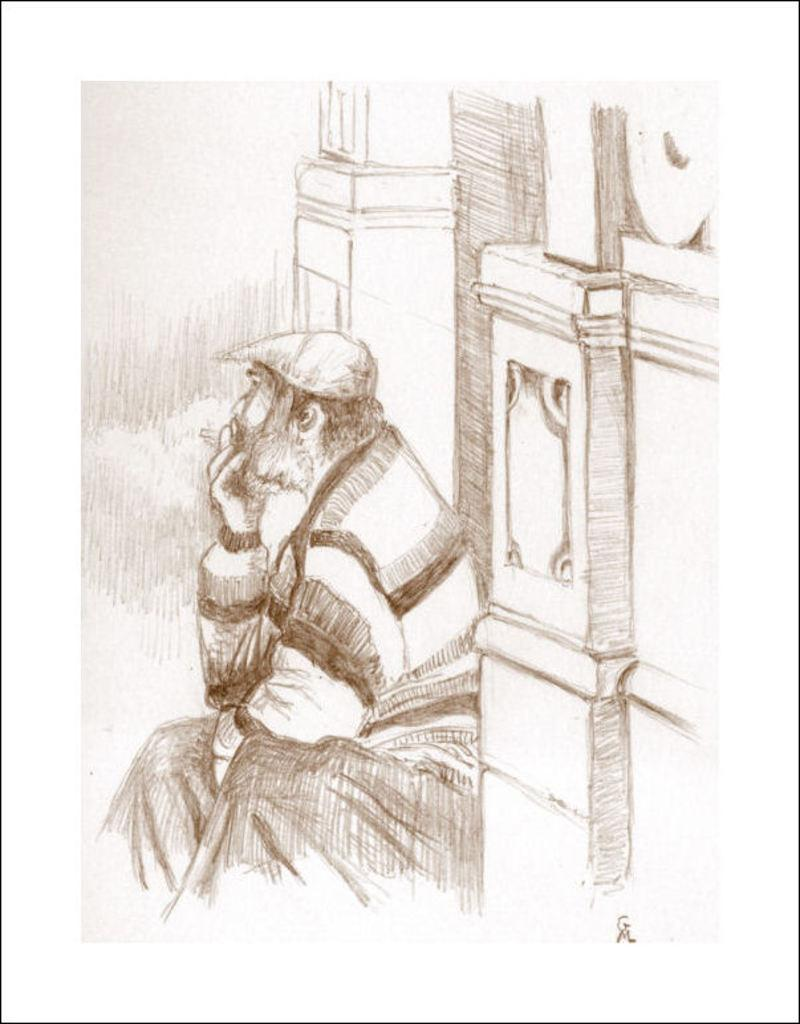What is the main subject of the drawing in the image? The main subject of the drawing in the image is a man sitting. What can be seen in the background of the drawing? There is a wall depicted in the background of the drawing. What direction is the bubble floating in the image? There is no bubble present in the image. How many feet does the man have in the drawing? The drawing only shows the man sitting, so it is not possible to determine the number of feet he has. 